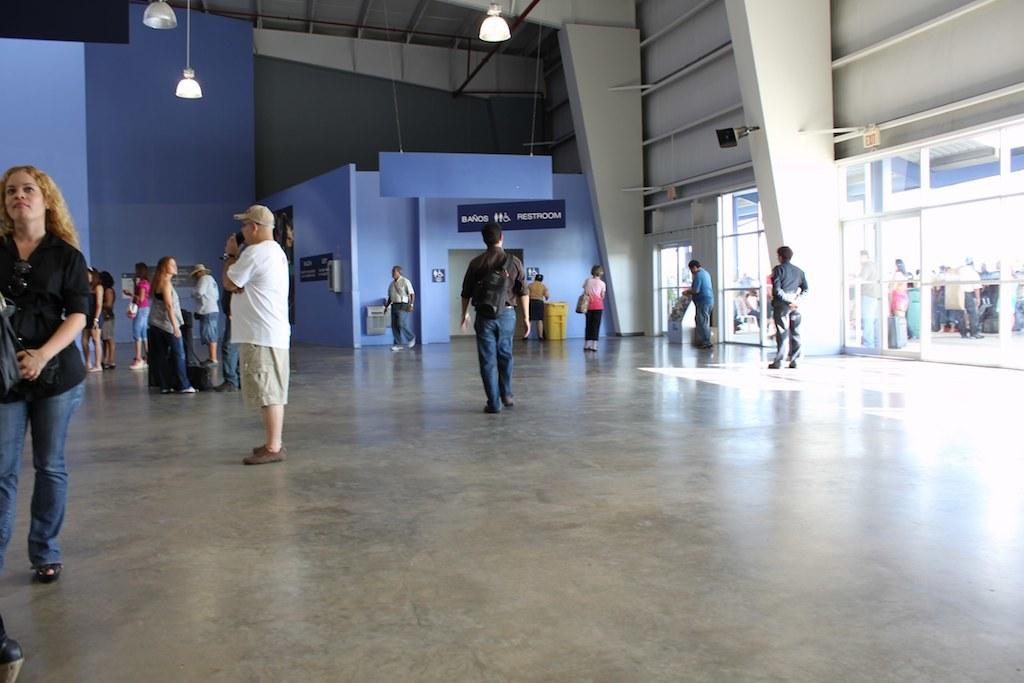How many people are present in the image? There are many people in the image. What can be seen in the background of the image? There is a room visible in the background. What object is present for disposing of waste? There is a dustbin in the image. What type of lighting is present in the image? There are lights on the ceiling. What type of rifle is being used by the servant in the image? There is no servant or rifle present in the image. How does the dustbin twist in the image? The dustbin does not twist in the image; it is stationary. 